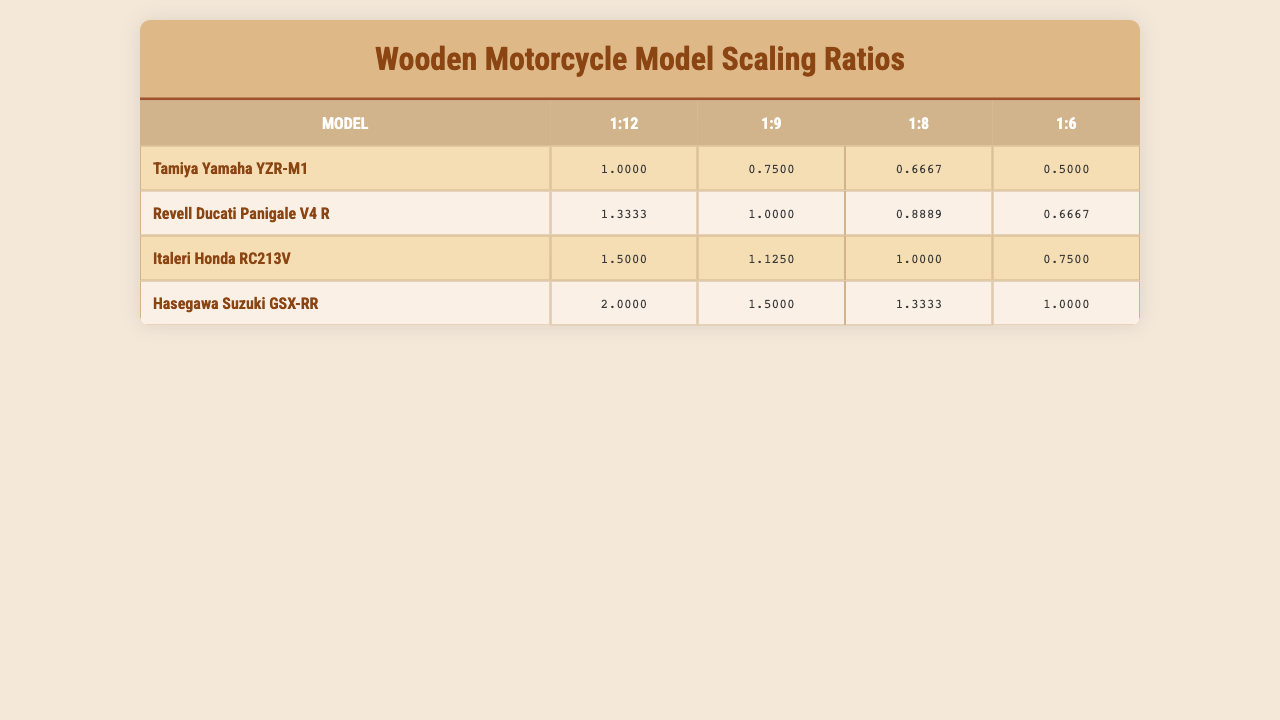What is the scaling ratio for the Tamiya Yamaha YZR-M1 in a 1:8 scale? According to the table, the scaling ratio for the Tamiya Yamaha YZR-M1 in a 1:8 scale is 0.6667.
Answer: 0.6667 Which model has the highest scaling ratio for the 1:6 scale? In the table, when looking at the 1:6 scale column, the highest scaling ratio is 2 from the Hasegawa Suzuki GSX-RR model.
Answer: Hasegawa Suzuki GSX-RR Is the scaling ratio for the Revell Ducati Panigale V4 R the same in 1:9 and 1:8 scales? In the table, the scaling ratio for the Revell Ducati Panigale V4 R in the 1:9 scale is 1, while in the 1:8 scale it is 0.8889. Since these values are different, the answer is no.
Answer: No What is the average scaling ratio for the Italeri Honda RC213V across all scales? The scaling ratios for Italeri Honda RC213V are 1.5, 1.125, 1, and 0.75. Adding these gives 1.5 + 1.125 + 1 + 0.75 = 4.375. There are 4 scaling ratios, so the average is 4.375 / 4 = 1.09375.
Answer: 1.09375 Which model has a scaling ratio of 0.5? By reviewing the table, the model with a scaling ratio of 0.5 is Tamiya Yamaha YZR-M1 in the 1:6 scale.
Answer: Tamiya Yamaha YZR-M1 What is the sum of the scaling ratios for all models in the 1:12 scale? The scaling ratios in the 1:12 scale are 1 for Tamiya Yamaha YZR-M1, 1.3333 for Revell Ducati Panigale V4 R, 1.5 for Italeri Honda RC213V, 2 for Hasegawa Suzuki GSX-RR, 1.5 for Aoshima Kawasaki Ninja ZX-RR, 1 for MiniArt BMW S1000RR, 1 for Academy Aprilia RS-GP, and 1 for Trumpeter KTM RC16. Adding these gives 1 + 1.3333 + 1.5 + 2 + 1.5 + 1 + 1 + 1 = 9.3333.
Answer: 9.3333 Is the scaling ratio of the MiniArt BMW S1000RR greater than 1 in the 1:8 scale? The scaling ratio for MiniArt BMW S1000RR in the 1:8 scale is 1, which is not greater than 1. Thus, the answer is no.
Answer: No What is the difference in scaling ratios between the Hasegawa Suzuki GSX-RR in 1:9 and 1:12 scales? The scaling ratio for Hasegawa Suzuki GSX-RR in 1:9 scale is 1.5, and in 1:12 scale, it is 2. The difference is 1.5 - 2 = -0.5.
Answer: -0.5 Which model has the same scaling ratio for 1:6 and 1:8 scales? By examining the table, Aoshima Kawasaki Ninja ZX-RR has the same scaling ratio of 1 for both the 1:6 and 1:8 scales.
Answer: Aoshima Kawasaki Ninja ZX-RR 